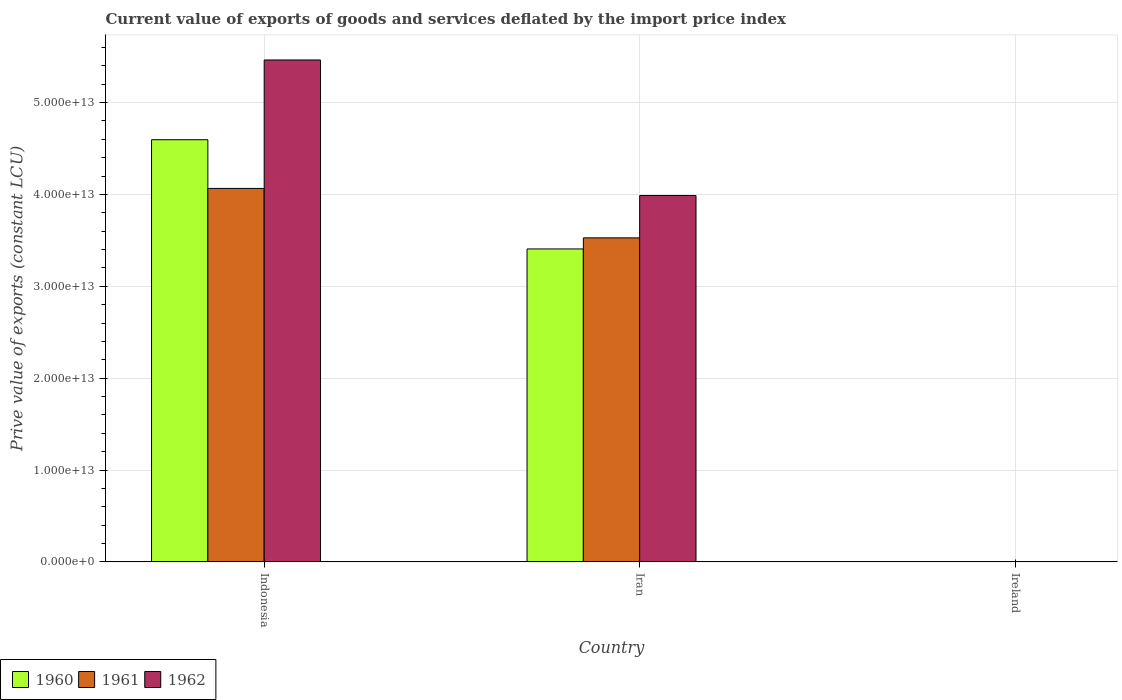How many different coloured bars are there?
Offer a terse response. 3. How many groups of bars are there?
Keep it short and to the point. 3. Are the number of bars per tick equal to the number of legend labels?
Give a very brief answer. Yes. How many bars are there on the 3rd tick from the left?
Ensure brevity in your answer.  3. How many bars are there on the 1st tick from the right?
Ensure brevity in your answer.  3. In how many cases, is the number of bars for a given country not equal to the number of legend labels?
Provide a succinct answer. 0. What is the prive value of exports in 1961 in Indonesia?
Ensure brevity in your answer.  4.07e+13. Across all countries, what is the maximum prive value of exports in 1960?
Give a very brief answer. 4.60e+13. Across all countries, what is the minimum prive value of exports in 1960?
Offer a very short reply. 2.78e+09. In which country was the prive value of exports in 1962 maximum?
Give a very brief answer. Indonesia. In which country was the prive value of exports in 1960 minimum?
Your response must be concise. Ireland. What is the total prive value of exports in 1960 in the graph?
Provide a short and direct response. 8.00e+13. What is the difference between the prive value of exports in 1960 in Indonesia and that in Iran?
Make the answer very short. 1.19e+13. What is the difference between the prive value of exports in 1962 in Indonesia and the prive value of exports in 1960 in Iran?
Your answer should be very brief. 2.06e+13. What is the average prive value of exports in 1961 per country?
Ensure brevity in your answer.  2.53e+13. What is the difference between the prive value of exports of/in 1961 and prive value of exports of/in 1962 in Ireland?
Provide a succinct answer. -9.94e+06. What is the ratio of the prive value of exports in 1960 in Indonesia to that in Iran?
Your answer should be compact. 1.35. Is the prive value of exports in 1962 in Iran less than that in Ireland?
Your answer should be compact. No. What is the difference between the highest and the second highest prive value of exports in 1962?
Offer a terse response. -3.99e+13. What is the difference between the highest and the lowest prive value of exports in 1960?
Offer a very short reply. 4.59e+13. In how many countries, is the prive value of exports in 1962 greater than the average prive value of exports in 1962 taken over all countries?
Give a very brief answer. 2. Is the sum of the prive value of exports in 1962 in Indonesia and Ireland greater than the maximum prive value of exports in 1961 across all countries?
Provide a short and direct response. Yes. What does the 2nd bar from the left in Iran represents?
Ensure brevity in your answer.  1961. How many countries are there in the graph?
Give a very brief answer. 3. What is the difference between two consecutive major ticks on the Y-axis?
Your answer should be very brief. 1.00e+13. Does the graph contain any zero values?
Make the answer very short. No. Where does the legend appear in the graph?
Your answer should be compact. Bottom left. How are the legend labels stacked?
Offer a very short reply. Horizontal. What is the title of the graph?
Your answer should be compact. Current value of exports of goods and services deflated by the import price index. Does "1994" appear as one of the legend labels in the graph?
Offer a terse response. No. What is the label or title of the X-axis?
Provide a succinct answer. Country. What is the label or title of the Y-axis?
Offer a terse response. Prive value of exports (constant LCU). What is the Prive value of exports (constant LCU) of 1960 in Indonesia?
Keep it short and to the point. 4.60e+13. What is the Prive value of exports (constant LCU) in 1961 in Indonesia?
Your response must be concise. 4.07e+13. What is the Prive value of exports (constant LCU) in 1962 in Indonesia?
Keep it short and to the point. 5.46e+13. What is the Prive value of exports (constant LCU) of 1960 in Iran?
Provide a succinct answer. 3.41e+13. What is the Prive value of exports (constant LCU) of 1961 in Iran?
Your answer should be compact. 3.53e+13. What is the Prive value of exports (constant LCU) in 1962 in Iran?
Give a very brief answer. 3.99e+13. What is the Prive value of exports (constant LCU) of 1960 in Ireland?
Your answer should be compact. 2.78e+09. What is the Prive value of exports (constant LCU) in 1961 in Ireland?
Provide a succinct answer. 3.22e+09. What is the Prive value of exports (constant LCU) of 1962 in Ireland?
Your response must be concise. 3.23e+09. Across all countries, what is the maximum Prive value of exports (constant LCU) in 1960?
Your response must be concise. 4.60e+13. Across all countries, what is the maximum Prive value of exports (constant LCU) of 1961?
Offer a terse response. 4.07e+13. Across all countries, what is the maximum Prive value of exports (constant LCU) of 1962?
Your answer should be compact. 5.46e+13. Across all countries, what is the minimum Prive value of exports (constant LCU) of 1960?
Your answer should be very brief. 2.78e+09. Across all countries, what is the minimum Prive value of exports (constant LCU) in 1961?
Ensure brevity in your answer.  3.22e+09. Across all countries, what is the minimum Prive value of exports (constant LCU) of 1962?
Give a very brief answer. 3.23e+09. What is the total Prive value of exports (constant LCU) in 1960 in the graph?
Your response must be concise. 8.00e+13. What is the total Prive value of exports (constant LCU) in 1961 in the graph?
Offer a very short reply. 7.59e+13. What is the total Prive value of exports (constant LCU) in 1962 in the graph?
Give a very brief answer. 9.45e+13. What is the difference between the Prive value of exports (constant LCU) in 1960 in Indonesia and that in Iran?
Keep it short and to the point. 1.19e+13. What is the difference between the Prive value of exports (constant LCU) of 1961 in Indonesia and that in Iran?
Provide a short and direct response. 5.38e+12. What is the difference between the Prive value of exports (constant LCU) in 1962 in Indonesia and that in Iran?
Ensure brevity in your answer.  1.48e+13. What is the difference between the Prive value of exports (constant LCU) of 1960 in Indonesia and that in Ireland?
Make the answer very short. 4.59e+13. What is the difference between the Prive value of exports (constant LCU) of 1961 in Indonesia and that in Ireland?
Keep it short and to the point. 4.06e+13. What is the difference between the Prive value of exports (constant LCU) in 1962 in Indonesia and that in Ireland?
Give a very brief answer. 5.46e+13. What is the difference between the Prive value of exports (constant LCU) in 1960 in Iran and that in Ireland?
Make the answer very short. 3.41e+13. What is the difference between the Prive value of exports (constant LCU) of 1961 in Iran and that in Ireland?
Make the answer very short. 3.53e+13. What is the difference between the Prive value of exports (constant LCU) of 1962 in Iran and that in Ireland?
Keep it short and to the point. 3.99e+13. What is the difference between the Prive value of exports (constant LCU) of 1960 in Indonesia and the Prive value of exports (constant LCU) of 1961 in Iran?
Keep it short and to the point. 1.07e+13. What is the difference between the Prive value of exports (constant LCU) in 1960 in Indonesia and the Prive value of exports (constant LCU) in 1962 in Iran?
Make the answer very short. 6.07e+12. What is the difference between the Prive value of exports (constant LCU) in 1961 in Indonesia and the Prive value of exports (constant LCU) in 1962 in Iran?
Ensure brevity in your answer.  7.73e+11. What is the difference between the Prive value of exports (constant LCU) in 1960 in Indonesia and the Prive value of exports (constant LCU) in 1961 in Ireland?
Your response must be concise. 4.59e+13. What is the difference between the Prive value of exports (constant LCU) of 1960 in Indonesia and the Prive value of exports (constant LCU) of 1962 in Ireland?
Your answer should be very brief. 4.59e+13. What is the difference between the Prive value of exports (constant LCU) in 1961 in Indonesia and the Prive value of exports (constant LCU) in 1962 in Ireland?
Keep it short and to the point. 4.06e+13. What is the difference between the Prive value of exports (constant LCU) of 1960 in Iran and the Prive value of exports (constant LCU) of 1961 in Ireland?
Your answer should be compact. 3.41e+13. What is the difference between the Prive value of exports (constant LCU) of 1960 in Iran and the Prive value of exports (constant LCU) of 1962 in Ireland?
Offer a terse response. 3.41e+13. What is the difference between the Prive value of exports (constant LCU) of 1961 in Iran and the Prive value of exports (constant LCU) of 1962 in Ireland?
Your response must be concise. 3.53e+13. What is the average Prive value of exports (constant LCU) of 1960 per country?
Give a very brief answer. 2.67e+13. What is the average Prive value of exports (constant LCU) of 1961 per country?
Offer a terse response. 2.53e+13. What is the average Prive value of exports (constant LCU) in 1962 per country?
Provide a succinct answer. 3.15e+13. What is the difference between the Prive value of exports (constant LCU) of 1960 and Prive value of exports (constant LCU) of 1961 in Indonesia?
Your response must be concise. 5.30e+12. What is the difference between the Prive value of exports (constant LCU) of 1960 and Prive value of exports (constant LCU) of 1962 in Indonesia?
Offer a terse response. -8.68e+12. What is the difference between the Prive value of exports (constant LCU) in 1961 and Prive value of exports (constant LCU) in 1962 in Indonesia?
Provide a succinct answer. -1.40e+13. What is the difference between the Prive value of exports (constant LCU) in 1960 and Prive value of exports (constant LCU) in 1961 in Iran?
Your response must be concise. -1.21e+12. What is the difference between the Prive value of exports (constant LCU) of 1960 and Prive value of exports (constant LCU) of 1962 in Iran?
Provide a short and direct response. -5.81e+12. What is the difference between the Prive value of exports (constant LCU) in 1961 and Prive value of exports (constant LCU) in 1962 in Iran?
Keep it short and to the point. -4.61e+12. What is the difference between the Prive value of exports (constant LCU) of 1960 and Prive value of exports (constant LCU) of 1961 in Ireland?
Offer a terse response. -4.39e+08. What is the difference between the Prive value of exports (constant LCU) of 1960 and Prive value of exports (constant LCU) of 1962 in Ireland?
Give a very brief answer. -4.49e+08. What is the difference between the Prive value of exports (constant LCU) in 1961 and Prive value of exports (constant LCU) in 1962 in Ireland?
Your answer should be compact. -9.94e+06. What is the ratio of the Prive value of exports (constant LCU) in 1960 in Indonesia to that in Iran?
Provide a succinct answer. 1.35. What is the ratio of the Prive value of exports (constant LCU) in 1961 in Indonesia to that in Iran?
Keep it short and to the point. 1.15. What is the ratio of the Prive value of exports (constant LCU) in 1962 in Indonesia to that in Iran?
Ensure brevity in your answer.  1.37. What is the ratio of the Prive value of exports (constant LCU) of 1960 in Indonesia to that in Ireland?
Your answer should be very brief. 1.65e+04. What is the ratio of the Prive value of exports (constant LCU) in 1961 in Indonesia to that in Ireland?
Provide a short and direct response. 1.26e+04. What is the ratio of the Prive value of exports (constant LCU) in 1962 in Indonesia to that in Ireland?
Provide a succinct answer. 1.69e+04. What is the ratio of the Prive value of exports (constant LCU) of 1960 in Iran to that in Ireland?
Your answer should be compact. 1.23e+04. What is the ratio of the Prive value of exports (constant LCU) in 1961 in Iran to that in Ireland?
Keep it short and to the point. 1.10e+04. What is the ratio of the Prive value of exports (constant LCU) in 1962 in Iran to that in Ireland?
Offer a very short reply. 1.24e+04. What is the difference between the highest and the second highest Prive value of exports (constant LCU) of 1960?
Your answer should be compact. 1.19e+13. What is the difference between the highest and the second highest Prive value of exports (constant LCU) of 1961?
Provide a succinct answer. 5.38e+12. What is the difference between the highest and the second highest Prive value of exports (constant LCU) in 1962?
Keep it short and to the point. 1.48e+13. What is the difference between the highest and the lowest Prive value of exports (constant LCU) in 1960?
Your response must be concise. 4.59e+13. What is the difference between the highest and the lowest Prive value of exports (constant LCU) of 1961?
Ensure brevity in your answer.  4.06e+13. What is the difference between the highest and the lowest Prive value of exports (constant LCU) of 1962?
Your answer should be very brief. 5.46e+13. 